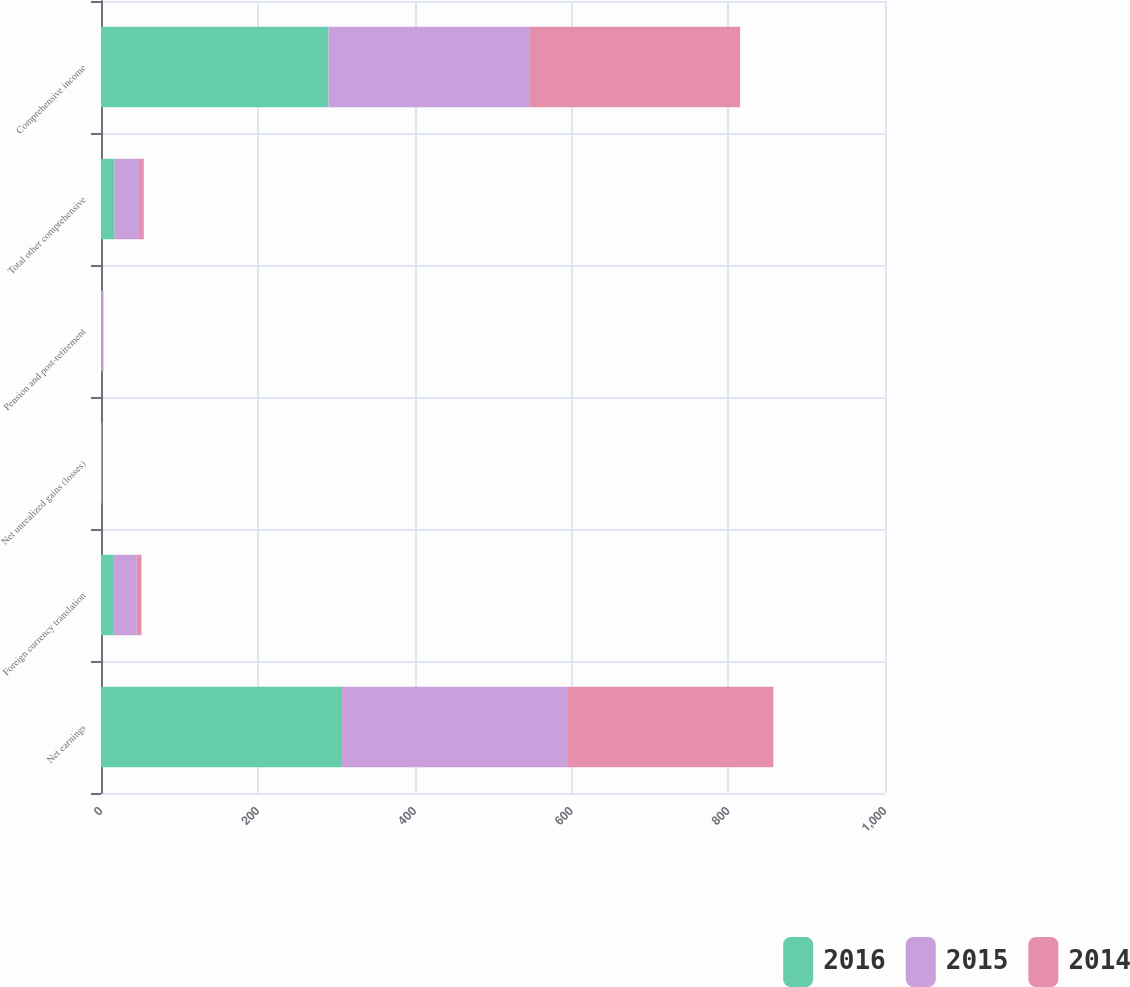Convert chart to OTSL. <chart><loc_0><loc_0><loc_500><loc_500><stacked_bar_chart><ecel><fcel>Net earnings<fcel>Foreign currency translation<fcel>Net unrealized gains (losses)<fcel>Pension and post-retirement<fcel>Total other comprehensive<fcel>Comprehensive income<nl><fcel>2016<fcel>307.5<fcel>15.4<fcel>0.7<fcel>1.3<fcel>17.3<fcel>290.2<nl><fcel>2015<fcel>287.1<fcel>30.2<fcel>0.1<fcel>1.1<fcel>31.2<fcel>255.9<nl><fcel>2014<fcel>263<fcel>6<fcel>0.8<fcel>0.7<fcel>6.1<fcel>269.1<nl></chart> 